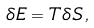<formula> <loc_0><loc_0><loc_500><loc_500>\delta E = T \delta S \, ,</formula> 